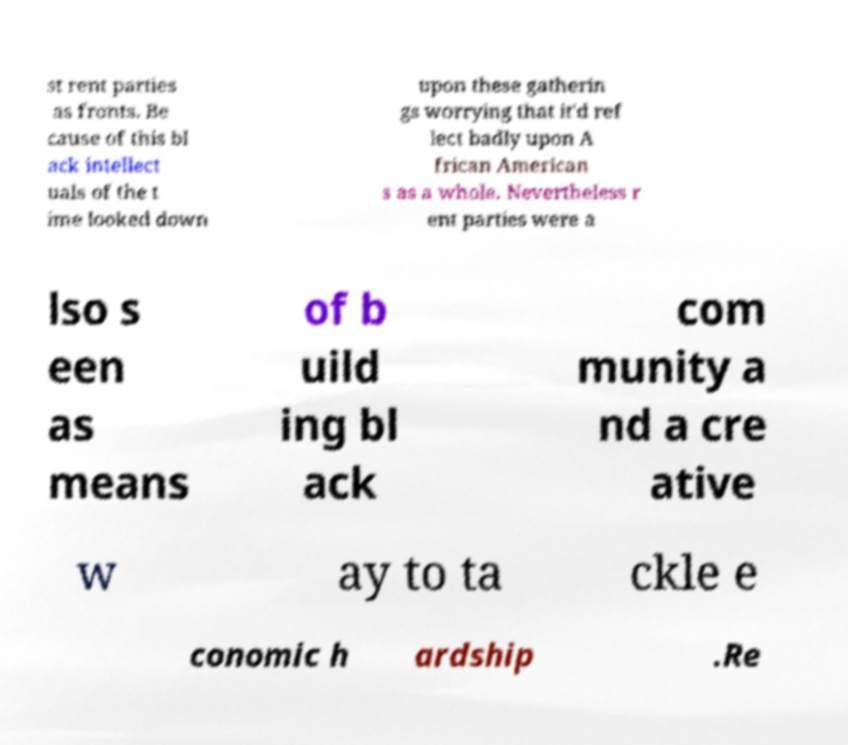Please read and relay the text visible in this image. What does it say? st rent parties as fronts. Be cause of this bl ack intellect uals of the t ime looked down upon these gatherin gs worrying that it'd ref lect badly upon A frican American s as a whole. Nevertheless r ent parties were a lso s een as means of b uild ing bl ack com munity a nd a cre ative w ay to ta ckle e conomic h ardship .Re 